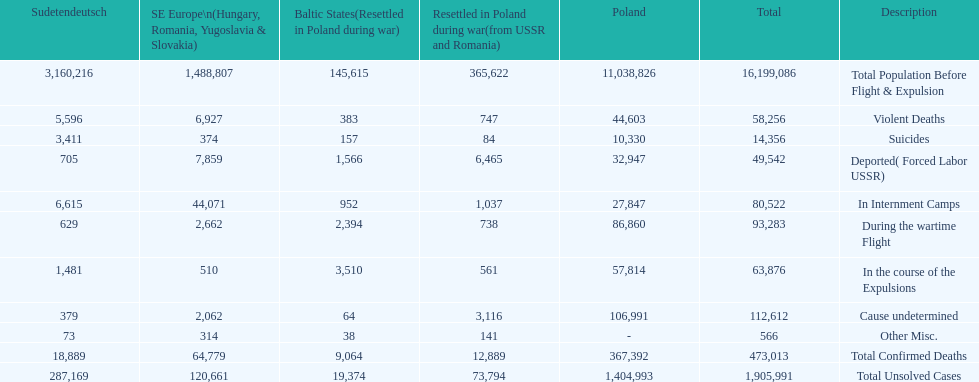Which country had the larger death tole? Poland. 